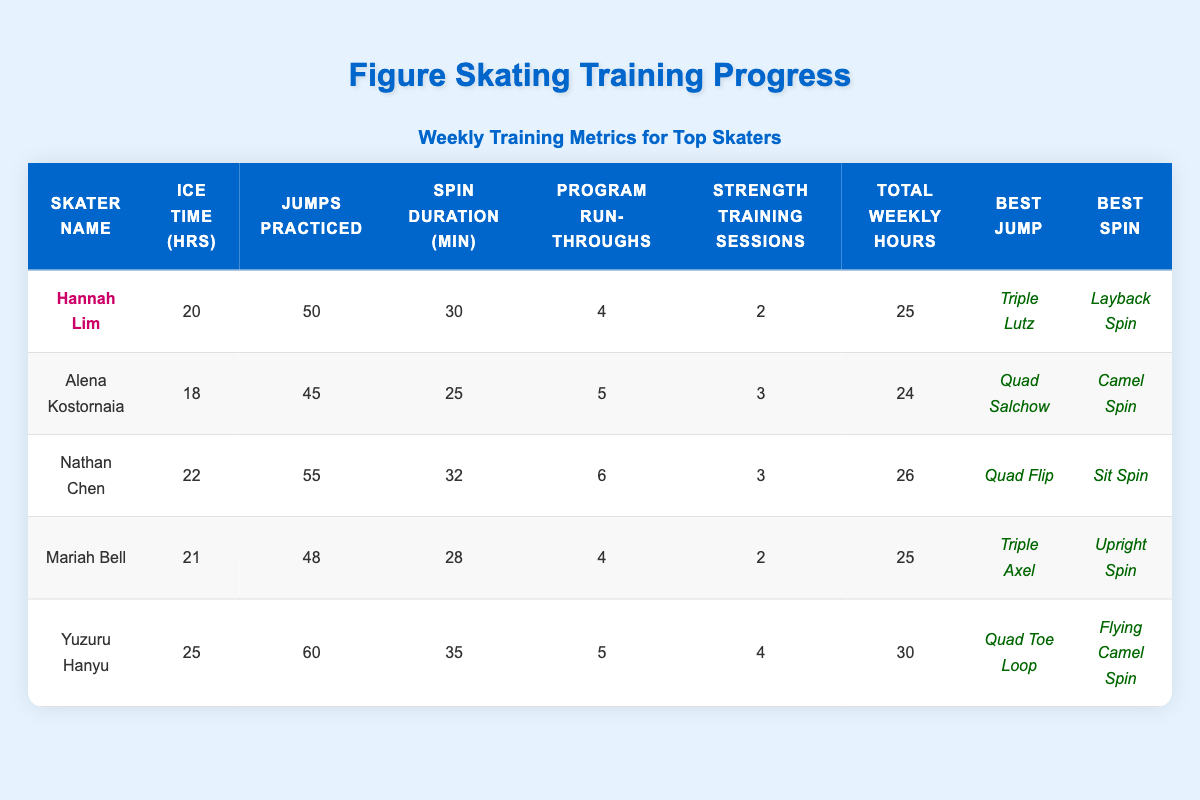What is Hannah Lim's best jump? The table shows that Hannah Lim's best jump is highlighted as "Triple Lutz."
Answer: Triple Lutz How many total weekly hours of training did Yuzuru Hanyu have? Yuzuru Hanyu's total weekly hours are listed as 30 in the table.
Answer: 30 Which skater practiced the most jumps? By comparing the Jumps Practiced column, Yuzuru Hanyu, with 60 jumps, practiced the most.
Answer: Yuzuru Hanyu What is the average ice time (in hours) across all skaters? Calculating the average: (20 + 18 + 22 + 21 + 25) / 5 = 106 / 5 = 21.2.
Answer: 21.2 Did Nathan Chen do more program run-throughs than Hannah Lim? Nathan Chen's run-throughs (6) are greater than Hannah Lim's (4), so yes.
Answer: Yes What is the difference in total weekly hours between Yuzuru Hanyu and Alena Kostornaia? The difference is calculated: 30 (Yuzuru) - 24 (Alena) = 6.
Answer: 6 Which skater has the highest spin duration? The table shows that Yuzuru Hanyu has the highest spin duration at 35 minutes.
Answer: Yuzuru Hanyu What is the total number of jumps practiced by all skaters combined? The total is calculated as: 50 + 45 + 55 + 48 + 60 = 258.
Answer: 258 Is Mariah Bell's best spin better than Hannah Lim's? Comparing the highlighted spins, 'Upright Spin' is not considered better than 'Layback Spin,' so the answer is no.
Answer: No Who had the least amount of ice time? Alena Kostornaia, with 18 ice time hours, had the least among the skaters.
Answer: Alena Kostornaia How many more strength training sessions did Yuzuru Hanyu have than Hannah Lim? The difference in sessions is: 4 (Yuzuru) - 2 (Hannah) = 2.
Answer: 2 